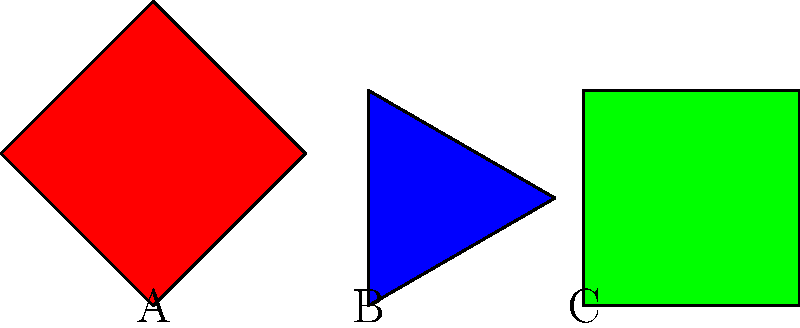Remember when we used to play with shape puzzles as kids? Look at these three shapes. Which one would fit perfectly into a square-shaped hole if rotated correctly? Let's approach this step-by-step, just like we used to solve puzzles together:

1. Shape A is a square that has been rotated 45 degrees. If we rotate it back by 45 degrees, it would fit perfectly into a square-shaped hole.

2. Shape B is an equilateral triangle. No matter how we rotate it, it will never fit perfectly into a square-shaped hole due to its triangular nature.

3. Shape C is already a square without any rotation. It would fit perfectly into a square-shaped hole without any need for rotation.

Both shapes A and C could fit into a square-shaped hole, but the question asks which one needs to be rotated correctly to fit. Therefore, the correct answer is Shape A, as it needs to be rotated back by 45 degrees to fit perfectly into a square-shaped hole.

Remember, just like in our childhood days, sometimes we need to look at things from different angles to find the right solution!
Answer: A 